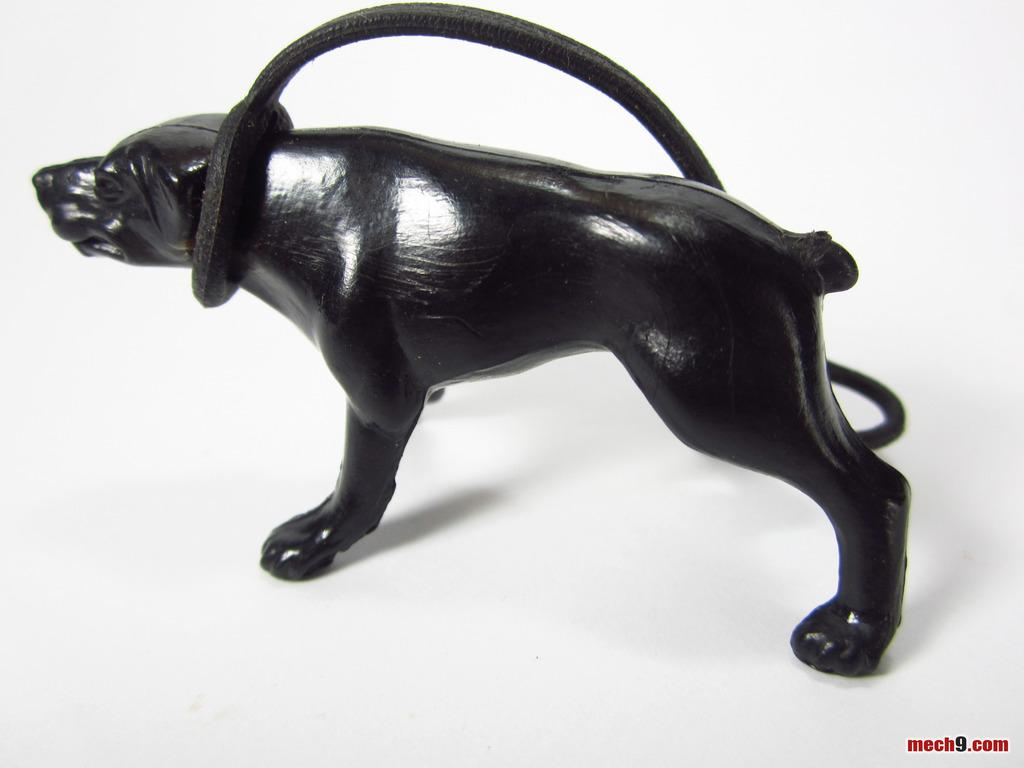What type of object is the main subject in the image? There is an animal toy in the image. Where is the animal toy located? The animal toy is on a platform. Is there any text present in the image? Yes, there is text written in the bottom corner on the right side of the image. How many matches are placed next to the animal toy in the image? There are no matches present in the image; it only features an animal toy on a platform and text in the bottom corner on the right side. 